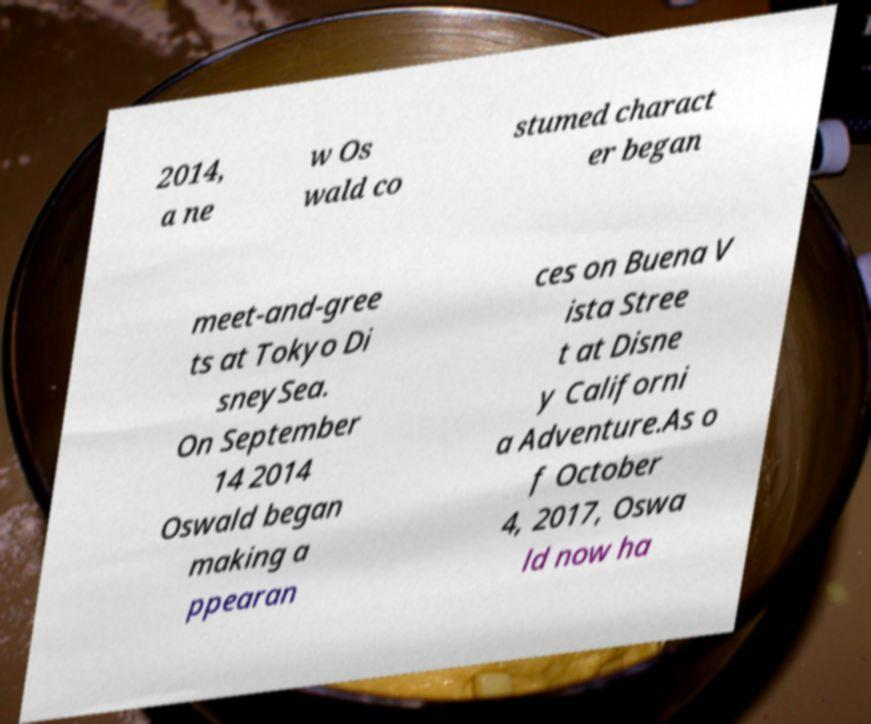There's text embedded in this image that I need extracted. Can you transcribe it verbatim? 2014, a ne w Os wald co stumed charact er began meet-and-gree ts at Tokyo Di sneySea. On September 14 2014 Oswald began making a ppearan ces on Buena V ista Stree t at Disne y Californi a Adventure.As o f October 4, 2017, Oswa ld now ha 